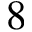Convert formula to latex. <formula><loc_0><loc_0><loc_500><loc_500>8</formula> 